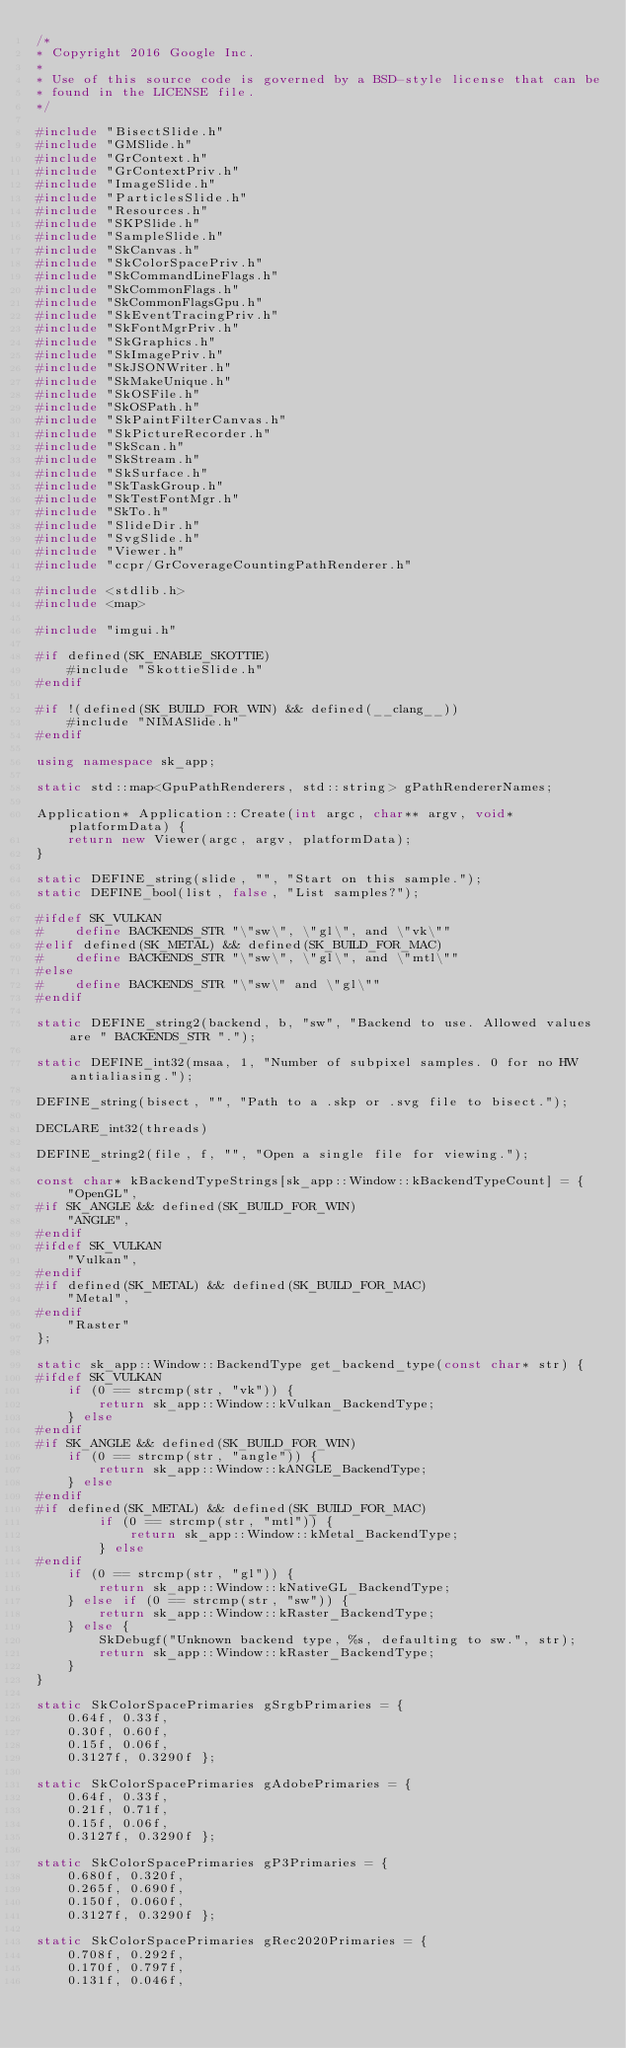<code> <loc_0><loc_0><loc_500><loc_500><_C++_>/*
* Copyright 2016 Google Inc.
*
* Use of this source code is governed by a BSD-style license that can be
* found in the LICENSE file.
*/

#include "BisectSlide.h"
#include "GMSlide.h"
#include "GrContext.h"
#include "GrContextPriv.h"
#include "ImageSlide.h"
#include "ParticlesSlide.h"
#include "Resources.h"
#include "SKPSlide.h"
#include "SampleSlide.h"
#include "SkCanvas.h"
#include "SkColorSpacePriv.h"
#include "SkCommandLineFlags.h"
#include "SkCommonFlags.h"
#include "SkCommonFlagsGpu.h"
#include "SkEventTracingPriv.h"
#include "SkFontMgrPriv.h"
#include "SkGraphics.h"
#include "SkImagePriv.h"
#include "SkJSONWriter.h"
#include "SkMakeUnique.h"
#include "SkOSFile.h"
#include "SkOSPath.h"
#include "SkPaintFilterCanvas.h"
#include "SkPictureRecorder.h"
#include "SkScan.h"
#include "SkStream.h"
#include "SkSurface.h"
#include "SkTaskGroup.h"
#include "SkTestFontMgr.h"
#include "SkTo.h"
#include "SlideDir.h"
#include "SvgSlide.h"
#include "Viewer.h"
#include "ccpr/GrCoverageCountingPathRenderer.h"

#include <stdlib.h>
#include <map>

#include "imgui.h"

#if defined(SK_ENABLE_SKOTTIE)
    #include "SkottieSlide.h"
#endif

#if !(defined(SK_BUILD_FOR_WIN) && defined(__clang__))
    #include "NIMASlide.h"
#endif

using namespace sk_app;

static std::map<GpuPathRenderers, std::string> gPathRendererNames;

Application* Application::Create(int argc, char** argv, void* platformData) {
    return new Viewer(argc, argv, platformData);
}

static DEFINE_string(slide, "", "Start on this sample.");
static DEFINE_bool(list, false, "List samples?");

#ifdef SK_VULKAN
#    define BACKENDS_STR "\"sw\", \"gl\", and \"vk\""
#elif defined(SK_METAL) && defined(SK_BUILD_FOR_MAC)
#    define BACKENDS_STR "\"sw\", \"gl\", and \"mtl\""
#else
#    define BACKENDS_STR "\"sw\" and \"gl\""
#endif

static DEFINE_string2(backend, b, "sw", "Backend to use. Allowed values are " BACKENDS_STR ".");

static DEFINE_int32(msaa, 1, "Number of subpixel samples. 0 for no HW antialiasing.");

DEFINE_string(bisect, "", "Path to a .skp or .svg file to bisect.");

DECLARE_int32(threads)

DEFINE_string2(file, f, "", "Open a single file for viewing.");

const char* kBackendTypeStrings[sk_app::Window::kBackendTypeCount] = {
    "OpenGL",
#if SK_ANGLE && defined(SK_BUILD_FOR_WIN)
    "ANGLE",
#endif
#ifdef SK_VULKAN
    "Vulkan",
#endif
#if defined(SK_METAL) && defined(SK_BUILD_FOR_MAC)
    "Metal",
#endif
    "Raster"
};

static sk_app::Window::BackendType get_backend_type(const char* str) {
#ifdef SK_VULKAN
    if (0 == strcmp(str, "vk")) {
        return sk_app::Window::kVulkan_BackendType;
    } else
#endif
#if SK_ANGLE && defined(SK_BUILD_FOR_WIN)
    if (0 == strcmp(str, "angle")) {
        return sk_app::Window::kANGLE_BackendType;
    } else
#endif
#if defined(SK_METAL) && defined(SK_BUILD_FOR_MAC)
        if (0 == strcmp(str, "mtl")) {
            return sk_app::Window::kMetal_BackendType;
        } else
#endif
    if (0 == strcmp(str, "gl")) {
        return sk_app::Window::kNativeGL_BackendType;
    } else if (0 == strcmp(str, "sw")) {
        return sk_app::Window::kRaster_BackendType;
    } else {
        SkDebugf("Unknown backend type, %s, defaulting to sw.", str);
        return sk_app::Window::kRaster_BackendType;
    }
}

static SkColorSpacePrimaries gSrgbPrimaries = {
    0.64f, 0.33f,
    0.30f, 0.60f,
    0.15f, 0.06f,
    0.3127f, 0.3290f };

static SkColorSpacePrimaries gAdobePrimaries = {
    0.64f, 0.33f,
    0.21f, 0.71f,
    0.15f, 0.06f,
    0.3127f, 0.3290f };

static SkColorSpacePrimaries gP3Primaries = {
    0.680f, 0.320f,
    0.265f, 0.690f,
    0.150f, 0.060f,
    0.3127f, 0.3290f };

static SkColorSpacePrimaries gRec2020Primaries = {
    0.708f, 0.292f,
    0.170f, 0.797f,
    0.131f, 0.046f,</code> 